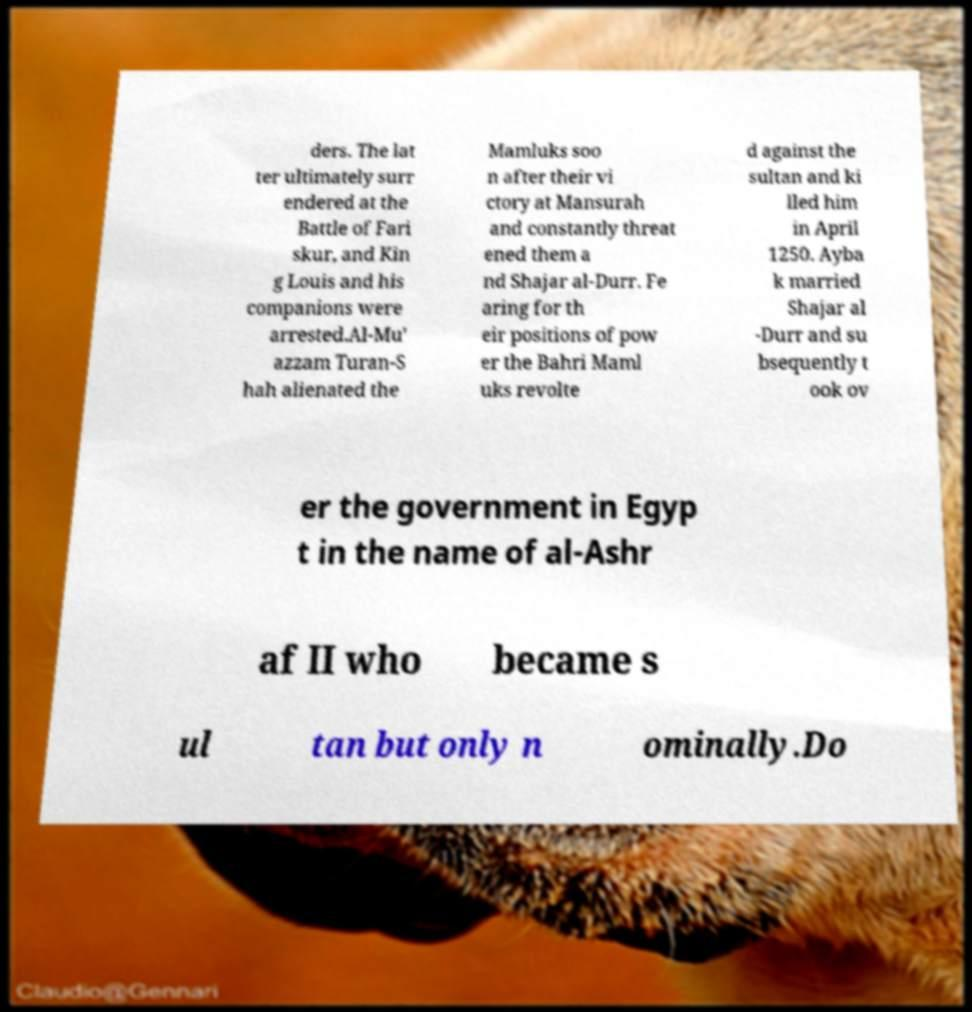Could you assist in decoding the text presented in this image and type it out clearly? ders. The lat ter ultimately surr endered at the Battle of Fari skur, and Kin g Louis and his companions were arrested.Al-Mu' azzam Turan-S hah alienated the Mamluks soo n after their vi ctory at Mansurah and constantly threat ened them a nd Shajar al-Durr. Fe aring for th eir positions of pow er the Bahri Maml uks revolte d against the sultan and ki lled him in April 1250. Ayba k married Shajar al -Durr and su bsequently t ook ov er the government in Egyp t in the name of al-Ashr af II who became s ul tan but only n ominally.Do 